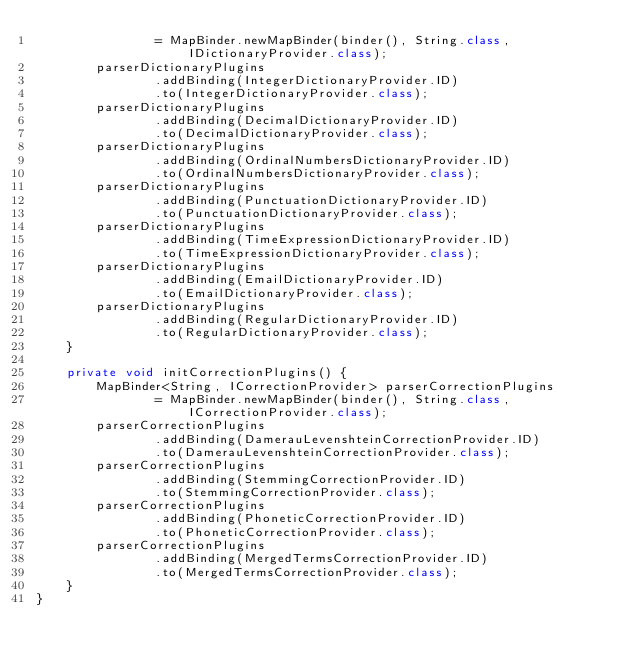Convert code to text. <code><loc_0><loc_0><loc_500><loc_500><_Java_>                = MapBinder.newMapBinder(binder(), String.class, IDictionaryProvider.class);
        parserDictionaryPlugins
                .addBinding(IntegerDictionaryProvider.ID)
                .to(IntegerDictionaryProvider.class);
        parserDictionaryPlugins
                .addBinding(DecimalDictionaryProvider.ID)
                .to(DecimalDictionaryProvider.class);
        parserDictionaryPlugins
                .addBinding(OrdinalNumbersDictionaryProvider.ID)
                .to(OrdinalNumbersDictionaryProvider.class);
        parserDictionaryPlugins
                .addBinding(PunctuationDictionaryProvider.ID)
                .to(PunctuationDictionaryProvider.class);
        parserDictionaryPlugins
                .addBinding(TimeExpressionDictionaryProvider.ID)
                .to(TimeExpressionDictionaryProvider.class);
        parserDictionaryPlugins
                .addBinding(EmailDictionaryProvider.ID)
                .to(EmailDictionaryProvider.class);
        parserDictionaryPlugins
                .addBinding(RegularDictionaryProvider.ID)
                .to(RegularDictionaryProvider.class);
    }

    private void initCorrectionPlugins() {
        MapBinder<String, ICorrectionProvider> parserCorrectionPlugins
                = MapBinder.newMapBinder(binder(), String.class, ICorrectionProvider.class);
        parserCorrectionPlugins
                .addBinding(DamerauLevenshteinCorrectionProvider.ID)
                .to(DamerauLevenshteinCorrectionProvider.class);
        parserCorrectionPlugins
                .addBinding(StemmingCorrectionProvider.ID)
                .to(StemmingCorrectionProvider.class);
        parserCorrectionPlugins
                .addBinding(PhoneticCorrectionProvider.ID)
                .to(PhoneticCorrectionProvider.class);
        parserCorrectionPlugins
                .addBinding(MergedTermsCorrectionProvider.ID)
                .to(MergedTermsCorrectionProvider.class);
    }
}
</code> 